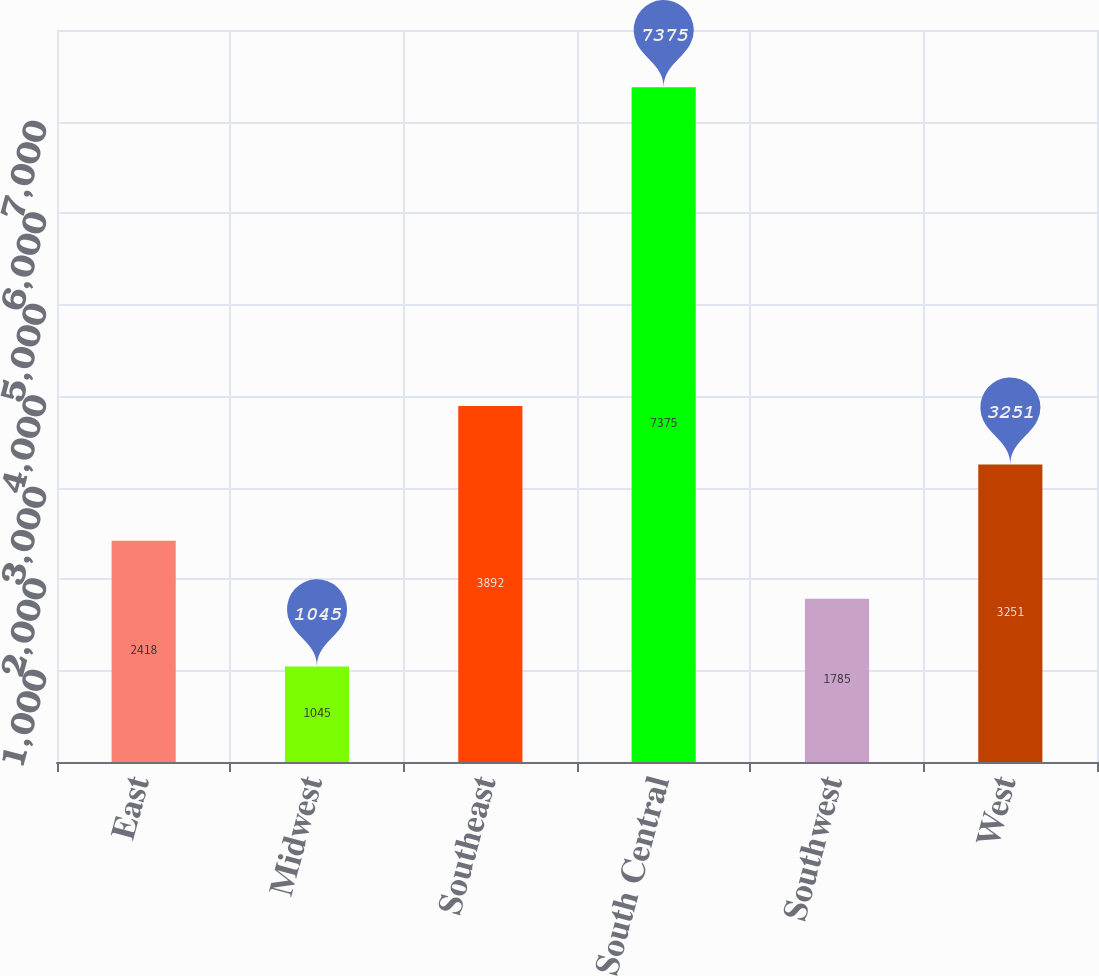Convert chart. <chart><loc_0><loc_0><loc_500><loc_500><bar_chart><fcel>East<fcel>Midwest<fcel>Southeast<fcel>South Central<fcel>Southwest<fcel>West<nl><fcel>2418<fcel>1045<fcel>3892<fcel>7375<fcel>1785<fcel>3251<nl></chart> 